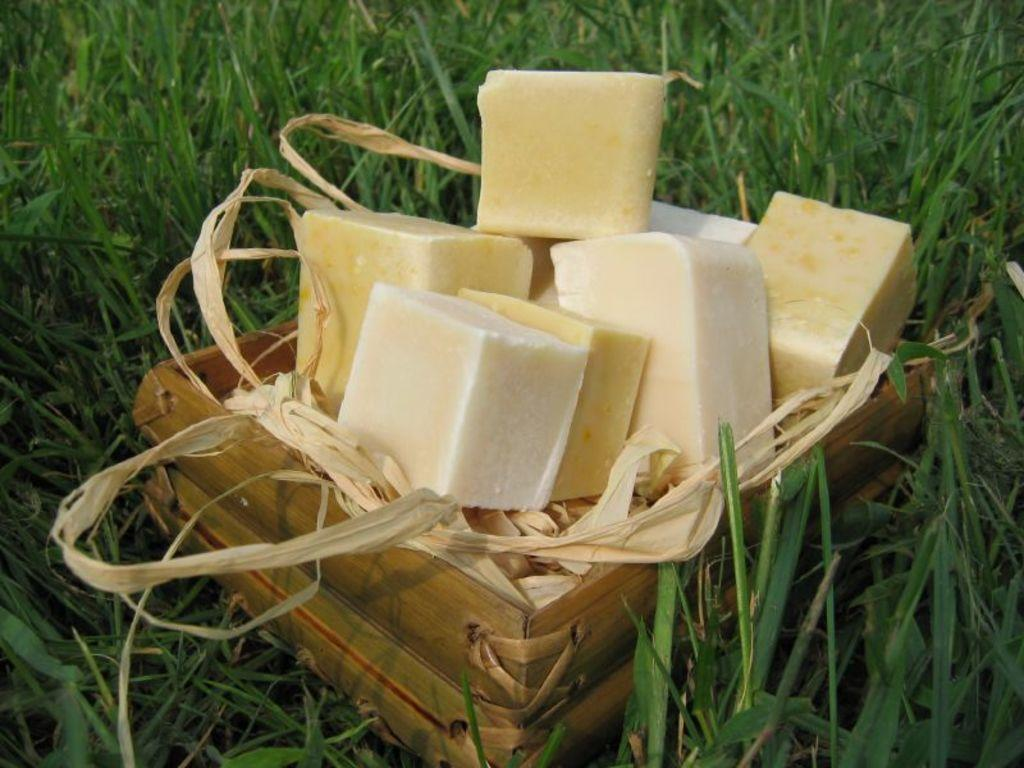What is in the basket that is visible in the image? There is a food item in a basket. Where is the basket located? The basket is on grass. How many babies are playing on the airplane during recess in the image? There is no airplane, babies, or recess present in the image. 